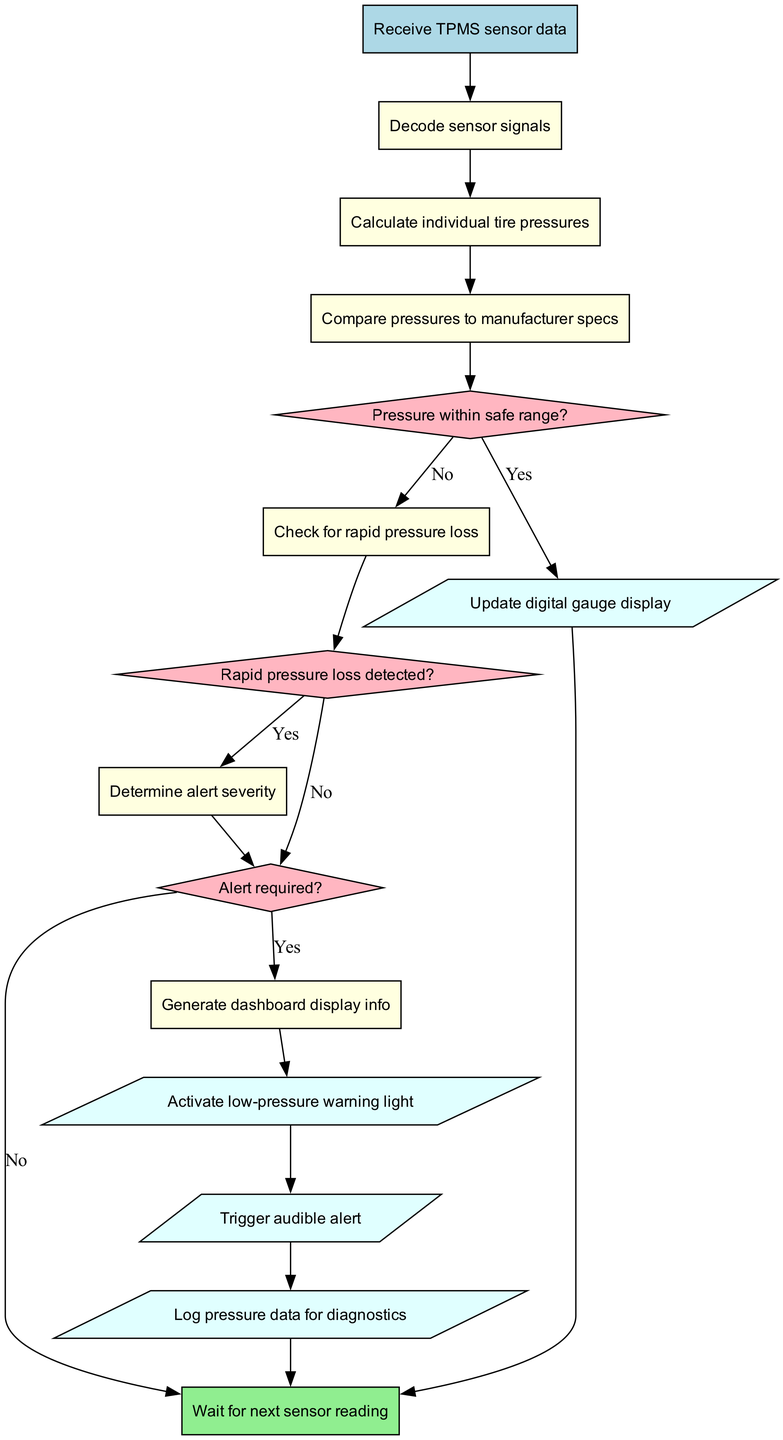What is the starting point of the flowchart? The diagram indicates that the starting point is labeled "Receive TPMS sensor data," which is the first node connected to the flow.
Answer: Receive TPMS sensor data How many processes are shown in the flowchart? The flowchart has a total of six processes listed, indicating the steps involved after receiving the TPMS data.
Answer: 6 What happens if the pressure is within the safe range? According to the diagram, if the pressure is within the safe range, the process outputs the information to "Update digital gauge display," indicating proper communication of the pressure status.
Answer: Update digital gauge display What is the output when a low-pressure alert is triggered? If a low-pressure alert is triggered, the flowchart indicates that it leads to the action "Activate low-pressure warning light," which serves as a visual warning.
Answer: Activate low-pressure warning light What determines whether an alert is required? The flowchart specifies that an alert is required based on the decision node labeled "Alert required?" which occurs after determining the severity of the situation, suggesting that multiple factors are considered before reaching this determination.
Answer: Alert required? If rapid pressure loss is detected, what is the next step? When rapid pressure loss is detected, the flowchart leads to the node "Determine alert severity," indicating that this situation necessitates additional processing to assess the urgency of the alert.
Answer: Determine alert severity How many outputs are listed in the flowchart? The diagram outlines four distinct outputs related to TPMS operations, which include actions to take based on tire pressure evaluations.
Answer: 4 What does the end node signify? The end node labeled "Wait for next sensor reading" signifies that the flowchart concludes the current cycle of processing and is ready to begin anew upon receiving further data from the sensors.
Answer: Wait for next sensor reading What happens if a decision checks for rapid pressure loss and it is not detected? If rapid pressure loss is not detected, the flowchart indicates it will lead to checking if an alert is required, meaning the process continues to evaluate the need for any additional alerts before progressing further.
Answer: Check for alert required? 